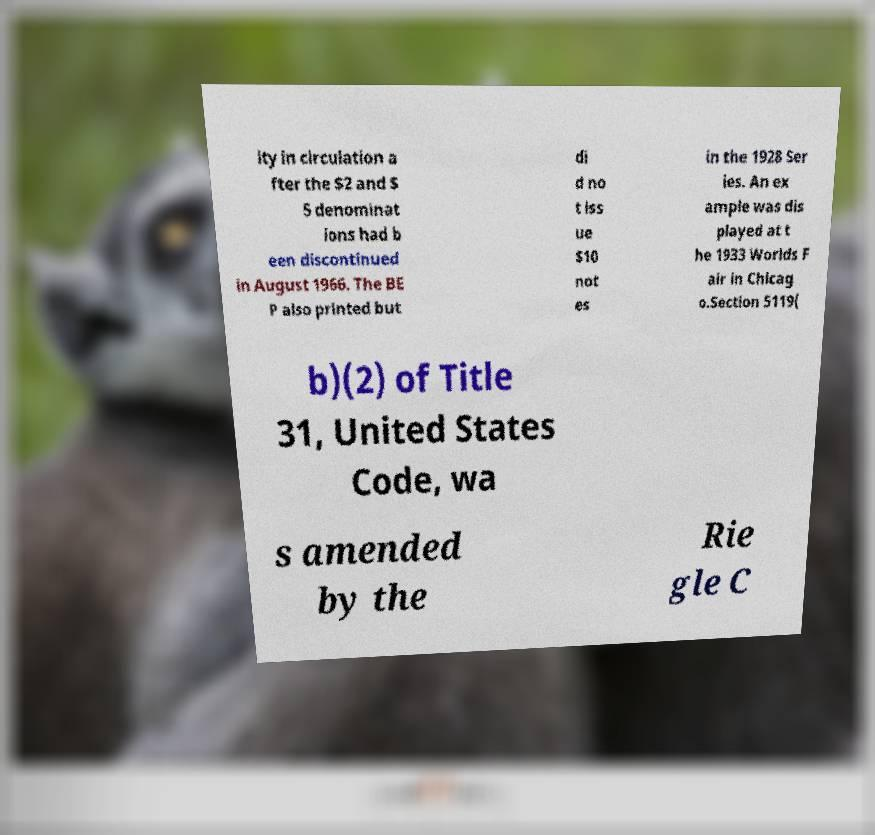Can you accurately transcribe the text from the provided image for me? ity in circulation a fter the $2 and $ 5 denominat ions had b een discontinued in August 1966. The BE P also printed but di d no t iss ue $10 not es in the 1928 Ser ies. An ex ample was dis played at t he 1933 Worlds F air in Chicag o.Section 5119( b)(2) of Title 31, United States Code, wa s amended by the Rie gle C 